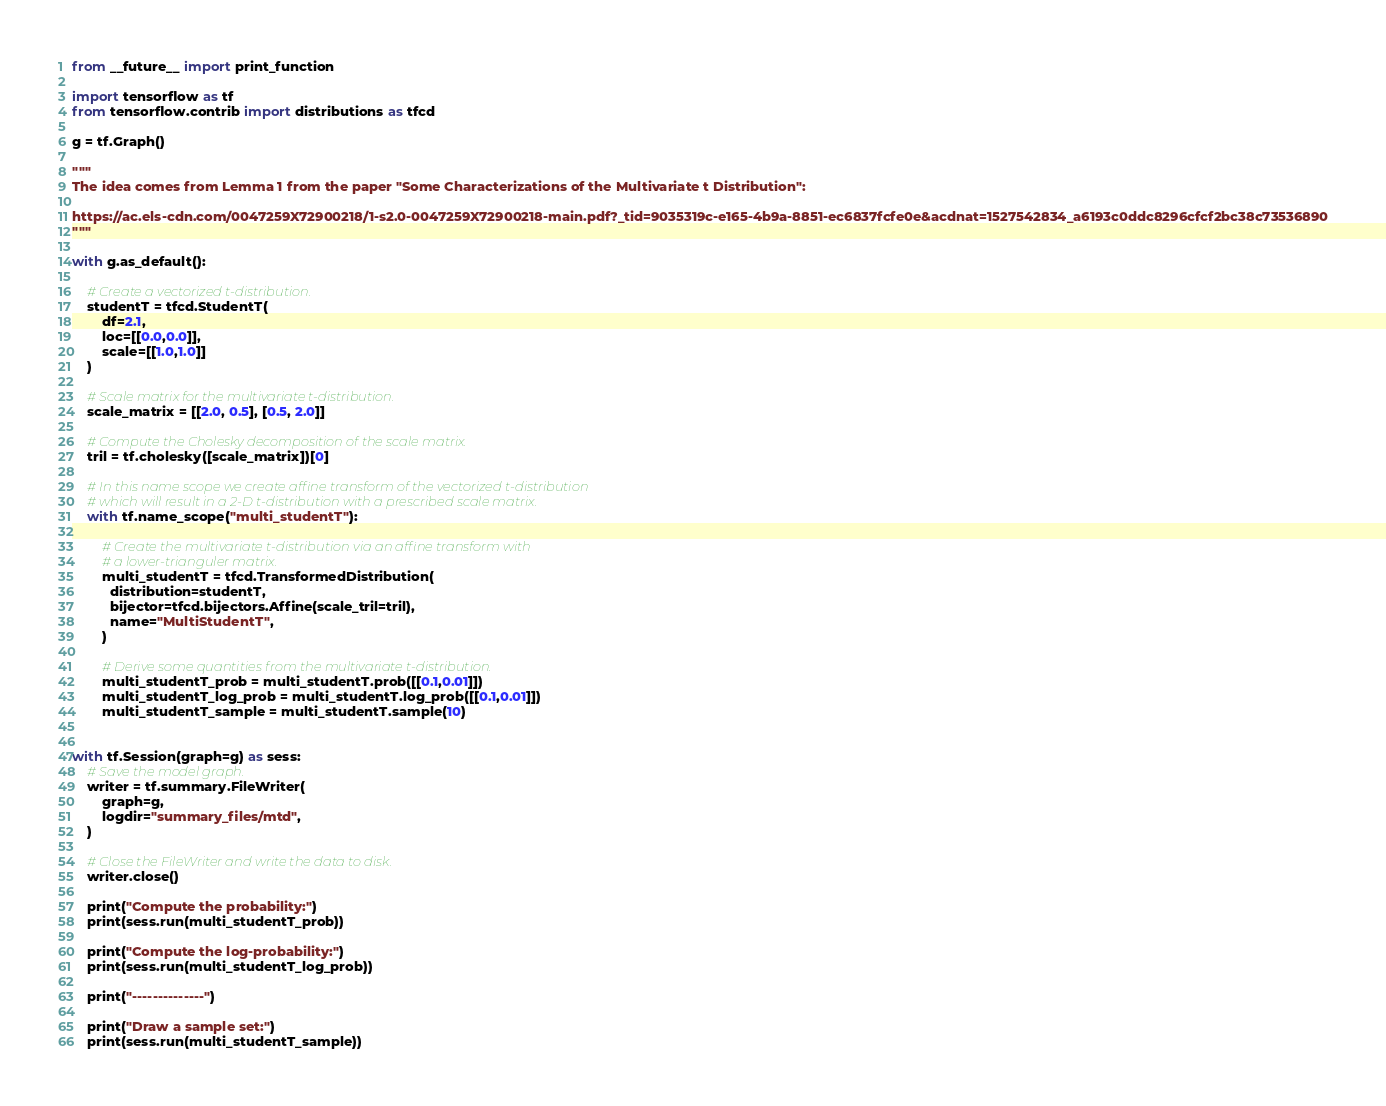Convert code to text. <code><loc_0><loc_0><loc_500><loc_500><_Python_>from __future__ import print_function

import tensorflow as tf
from tensorflow.contrib import distributions as tfcd

g = tf.Graph()

"""
The idea comes from Lemma 1 from the paper "Some Characterizations of the Multivariate t Distribution":

https://ac.els-cdn.com/0047259X72900218/1-s2.0-0047259X72900218-main.pdf?_tid=9035319c-e165-4b9a-8851-ec6837fcfe0e&acdnat=1527542834_a6193c0ddc8296cfcf2bc38c73536890
"""

with g.as_default():
    
    # Create a vectorized t-distribution.
    studentT = tfcd.StudentT(
        df=2.1,
        loc=[[0.0,0.0]],
        scale=[[1.0,1.0]]
    )
    
    # Scale matrix for the multivariate t-distribution.
    scale_matrix = [[2.0, 0.5], [0.5, 2.0]]
    
    # Compute the Cholesky decomposition of the scale matrix.
    tril = tf.cholesky([scale_matrix])[0]
    
    # In this name scope we create affine transform of the vectorized t-distribution
    # which will result in a 2-D t-distribution with a prescribed scale matrix.
    with tf.name_scope("multi_studentT"):
    
        # Create the multivariate t-distribution via an affine transform with
        # a lower-trianguler matrix.
        multi_studentT = tfcd.TransformedDistribution(
          distribution=studentT,
          bijector=tfcd.bijectors.Affine(scale_tril=tril),
          name="MultiStudentT",
        )
        
        # Derive some quantities from the multivariate t-distribution.
        multi_studentT_prob = multi_studentT.prob([[0.1,0.01]])
        multi_studentT_log_prob = multi_studentT.log_prob([[0.1,0.01]])
        multi_studentT_sample = multi_studentT.sample(10)
    

with tf.Session(graph=g) as sess:
    # Save the model graph.
    writer = tf.summary.FileWriter(
        graph=g,
        logdir="summary_files/mtd",
    )
    
    # Close the FileWriter and write the data to disk.
    writer.close()
    
    print("Compute the probability:")
    print(sess.run(multi_studentT_prob))
    
    print("Compute the log-probability:")
    print(sess.run(multi_studentT_log_prob))
    
    print("--------------")
    
    print("Draw a sample set:")
    print(sess.run(multi_studentT_sample))
</code> 